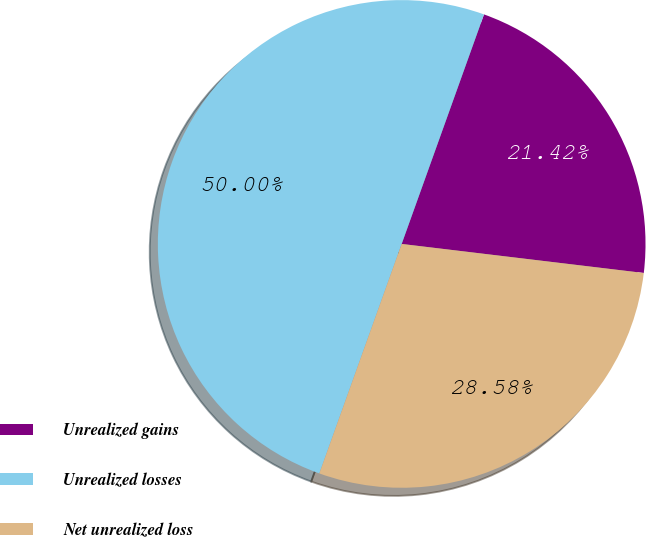Convert chart to OTSL. <chart><loc_0><loc_0><loc_500><loc_500><pie_chart><fcel>Unrealized gains<fcel>Unrealized losses<fcel>Net unrealized loss<nl><fcel>21.42%<fcel>50.0%<fcel>28.58%<nl></chart> 